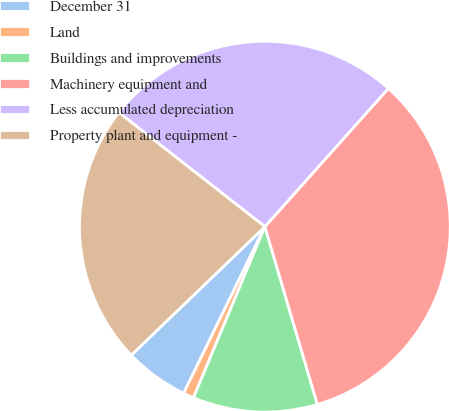Convert chart to OTSL. <chart><loc_0><loc_0><loc_500><loc_500><pie_chart><fcel>December 31<fcel>Land<fcel>Buildings and improvements<fcel>Machinery equipment and<fcel>Less accumulated depreciation<fcel>Property plant and equipment -<nl><fcel>5.59%<fcel>0.93%<fcel>10.86%<fcel>33.83%<fcel>26.04%<fcel>22.75%<nl></chart> 